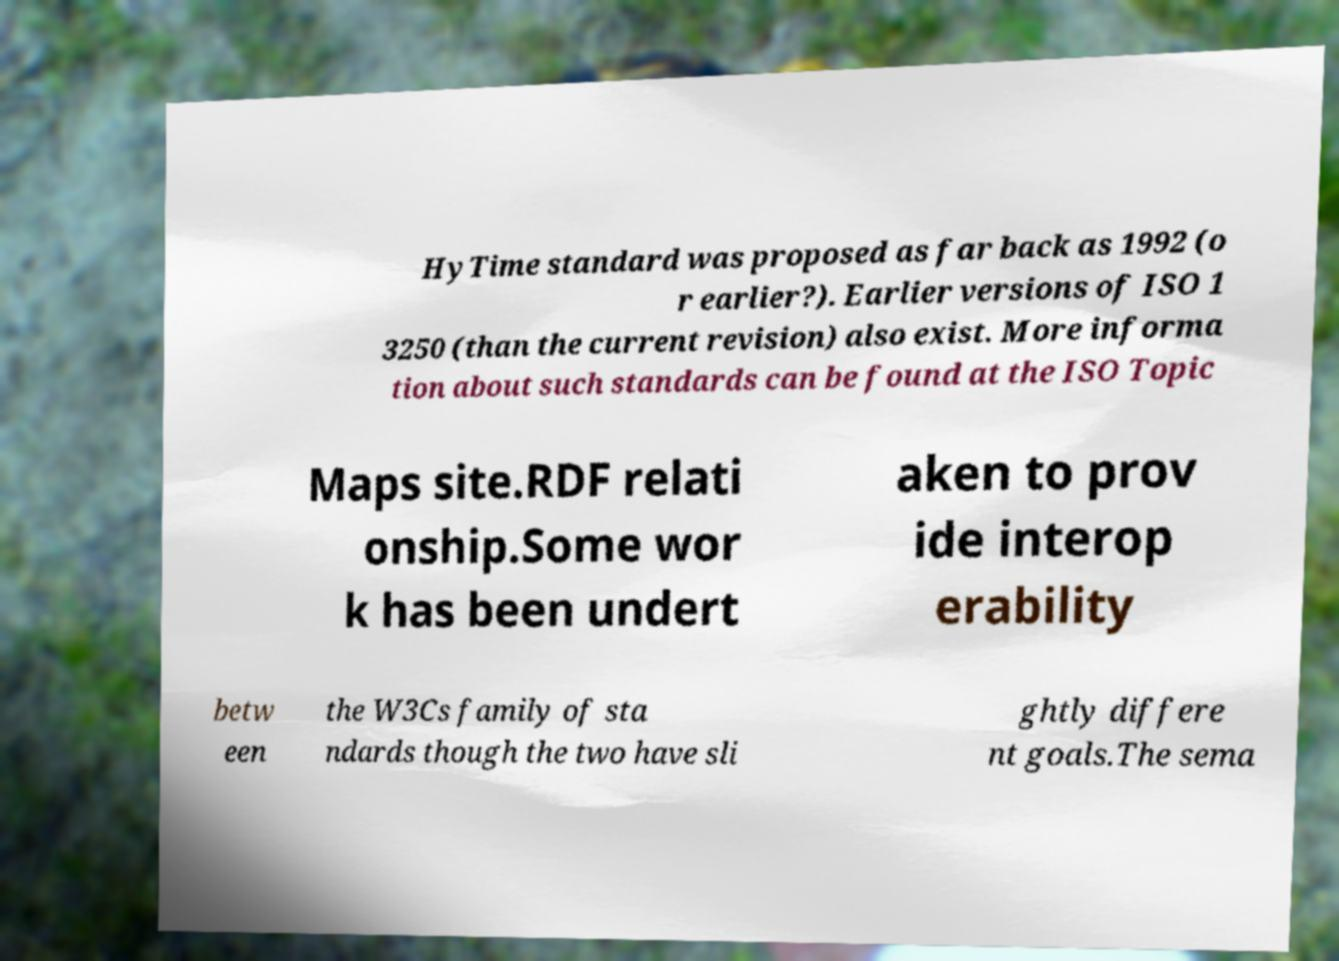There's text embedded in this image that I need extracted. Can you transcribe it verbatim? HyTime standard was proposed as far back as 1992 (o r earlier?). Earlier versions of ISO 1 3250 (than the current revision) also exist. More informa tion about such standards can be found at the ISO Topic Maps site.RDF relati onship.Some wor k has been undert aken to prov ide interop erability betw een the W3Cs family of sta ndards though the two have sli ghtly differe nt goals.The sema 